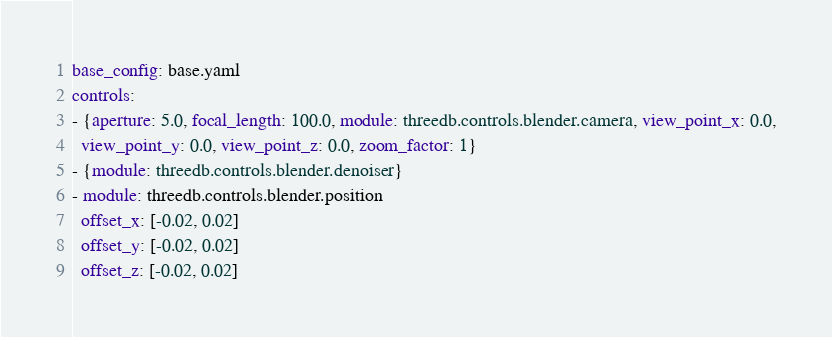Convert code to text. <code><loc_0><loc_0><loc_500><loc_500><_YAML_>base_config: base.yaml
controls:
- {aperture: 5.0, focal_length: 100.0, module: threedb.controls.blender.camera, view_point_x: 0.0,
  view_point_y: 0.0, view_point_z: 0.0, zoom_factor: 1}
- {module: threedb.controls.blender.denoiser}
- module: threedb.controls.blender.position
  offset_x: [-0.02, 0.02]
  offset_y: [-0.02, 0.02]
  offset_z: [-0.02, 0.02]</code> 